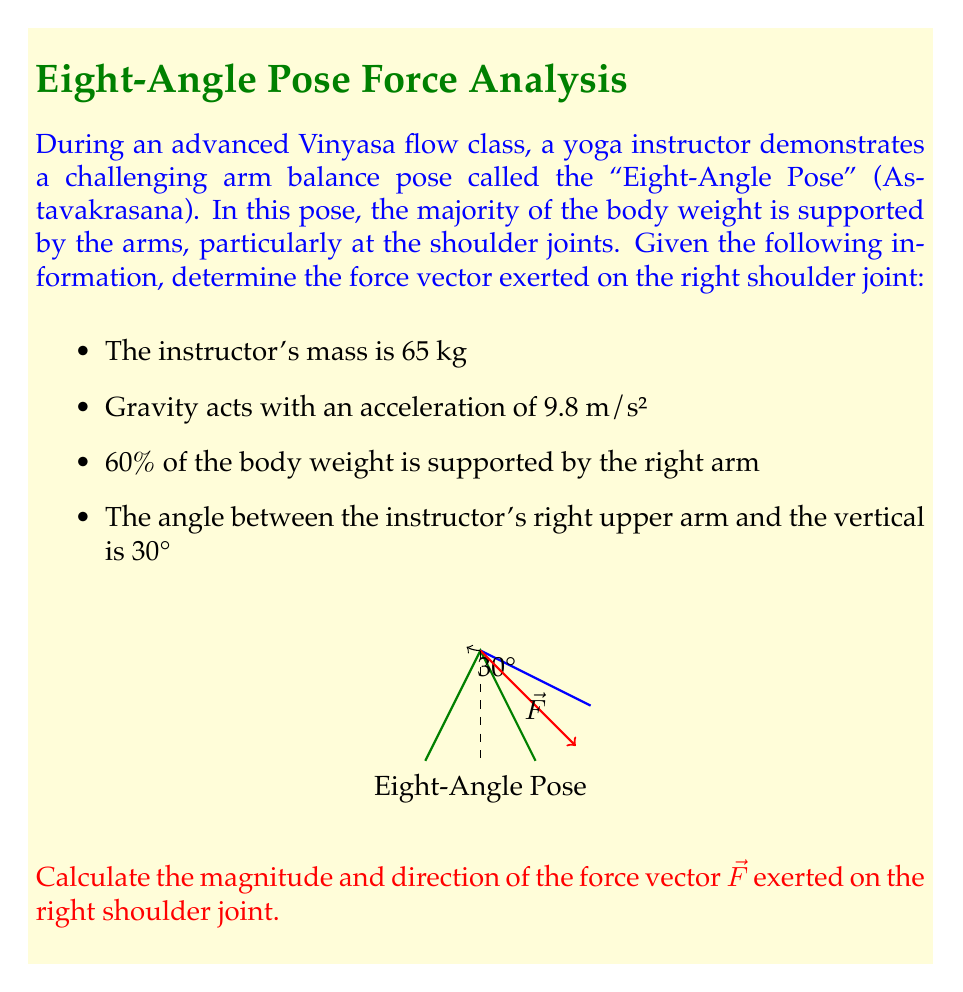Provide a solution to this math problem. Let's approach this problem step-by-step:

1) First, calculate the total weight of the instructor:
   $W = mg = 65 \text{ kg} \times 9.8 \text{ m/s}^2 = 637 \text{ N}$

2) The right arm supports 60% of the body weight:
   $F_{\text{total}} = 0.60 \times 637 \text{ N} = 382.2 \text{ N}$

3) This force acts along the arm, which is at a 30° angle from the vertical. We need to decompose this force into vertical and horizontal components:

   $F_y = F_{\text{total}} \cos 30° = 382.2 \text{ N} \times \cos 30° = 331.0 \text{ N}$
   $F_x = F_{\text{total}} \sin 30° = 382.2 \text{ N} \times \sin 30° = 191.1 \text{ N}$

4) The force vector $\vec{F}$ can be expressed as:
   $\vec{F} = 191.1\hat{i} + 331.0\hat{j} \text{ N}$

5) The magnitude of the force vector is:
   $|\vec{F}| = \sqrt{(191.1)^2 + (331.0)^2} = 382.2 \text{ N}$

6) The direction of the force vector can be found using the arctangent function:
   $\theta = \tan^{-1}(\frac{331.0}{191.1}) = 60°$

   This angle is measured from the positive x-axis (horizontal) in the counterclockwise direction.

Therefore, the force vector $\vec{F}$ exerted on the right shoulder joint has a magnitude of 382.2 N and acts at an angle of 60° above the horizontal.
Answer: $\vec{F} = 382.2 \text{ N}$ at $60°$ above horizontal 